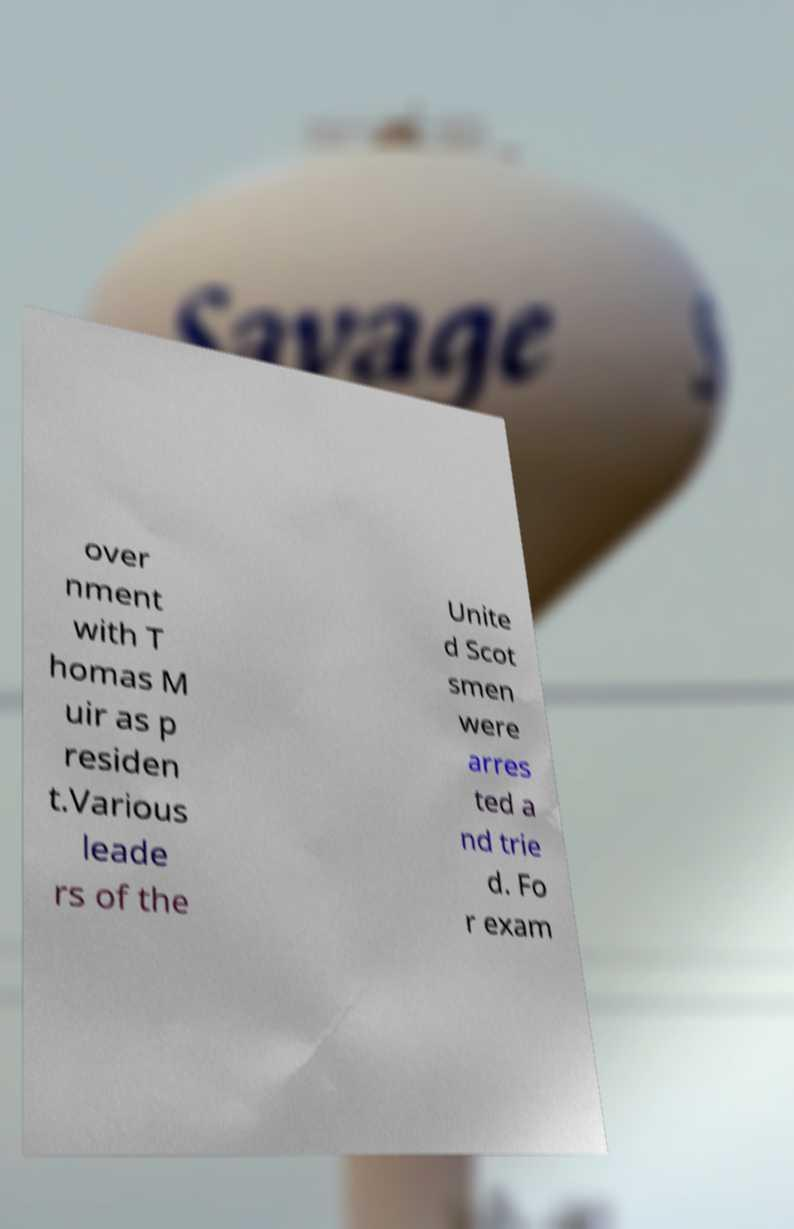Could you assist in decoding the text presented in this image and type it out clearly? over nment with T homas M uir as p residen t.Various leade rs of the Unite d Scot smen were arres ted a nd trie d. Fo r exam 